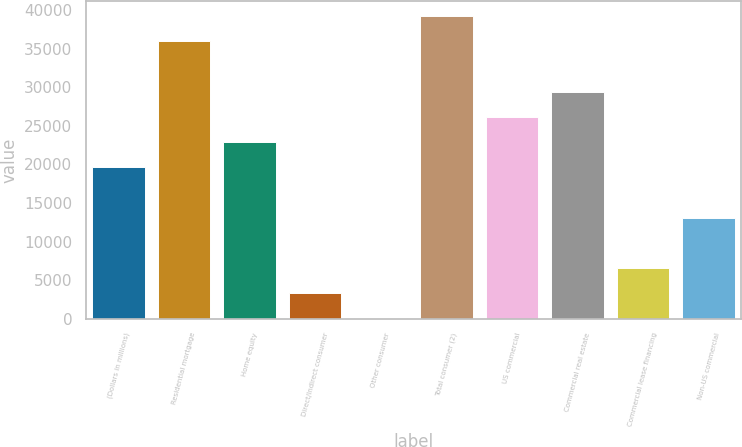Convert chart. <chart><loc_0><loc_0><loc_500><loc_500><bar_chart><fcel>(Dollars in millions)<fcel>Residential mortgage<fcel>Home equity<fcel>Direct/Indirect consumer<fcel>Other consumer<fcel>Total consumer (2)<fcel>US commercial<fcel>Commercial real estate<fcel>Commercial lease financing<fcel>Non-US commercial<nl><fcel>19617.6<fcel>35925.6<fcel>22879.2<fcel>3309.6<fcel>48<fcel>39187.2<fcel>26140.8<fcel>29402.4<fcel>6571.2<fcel>13094.4<nl></chart> 